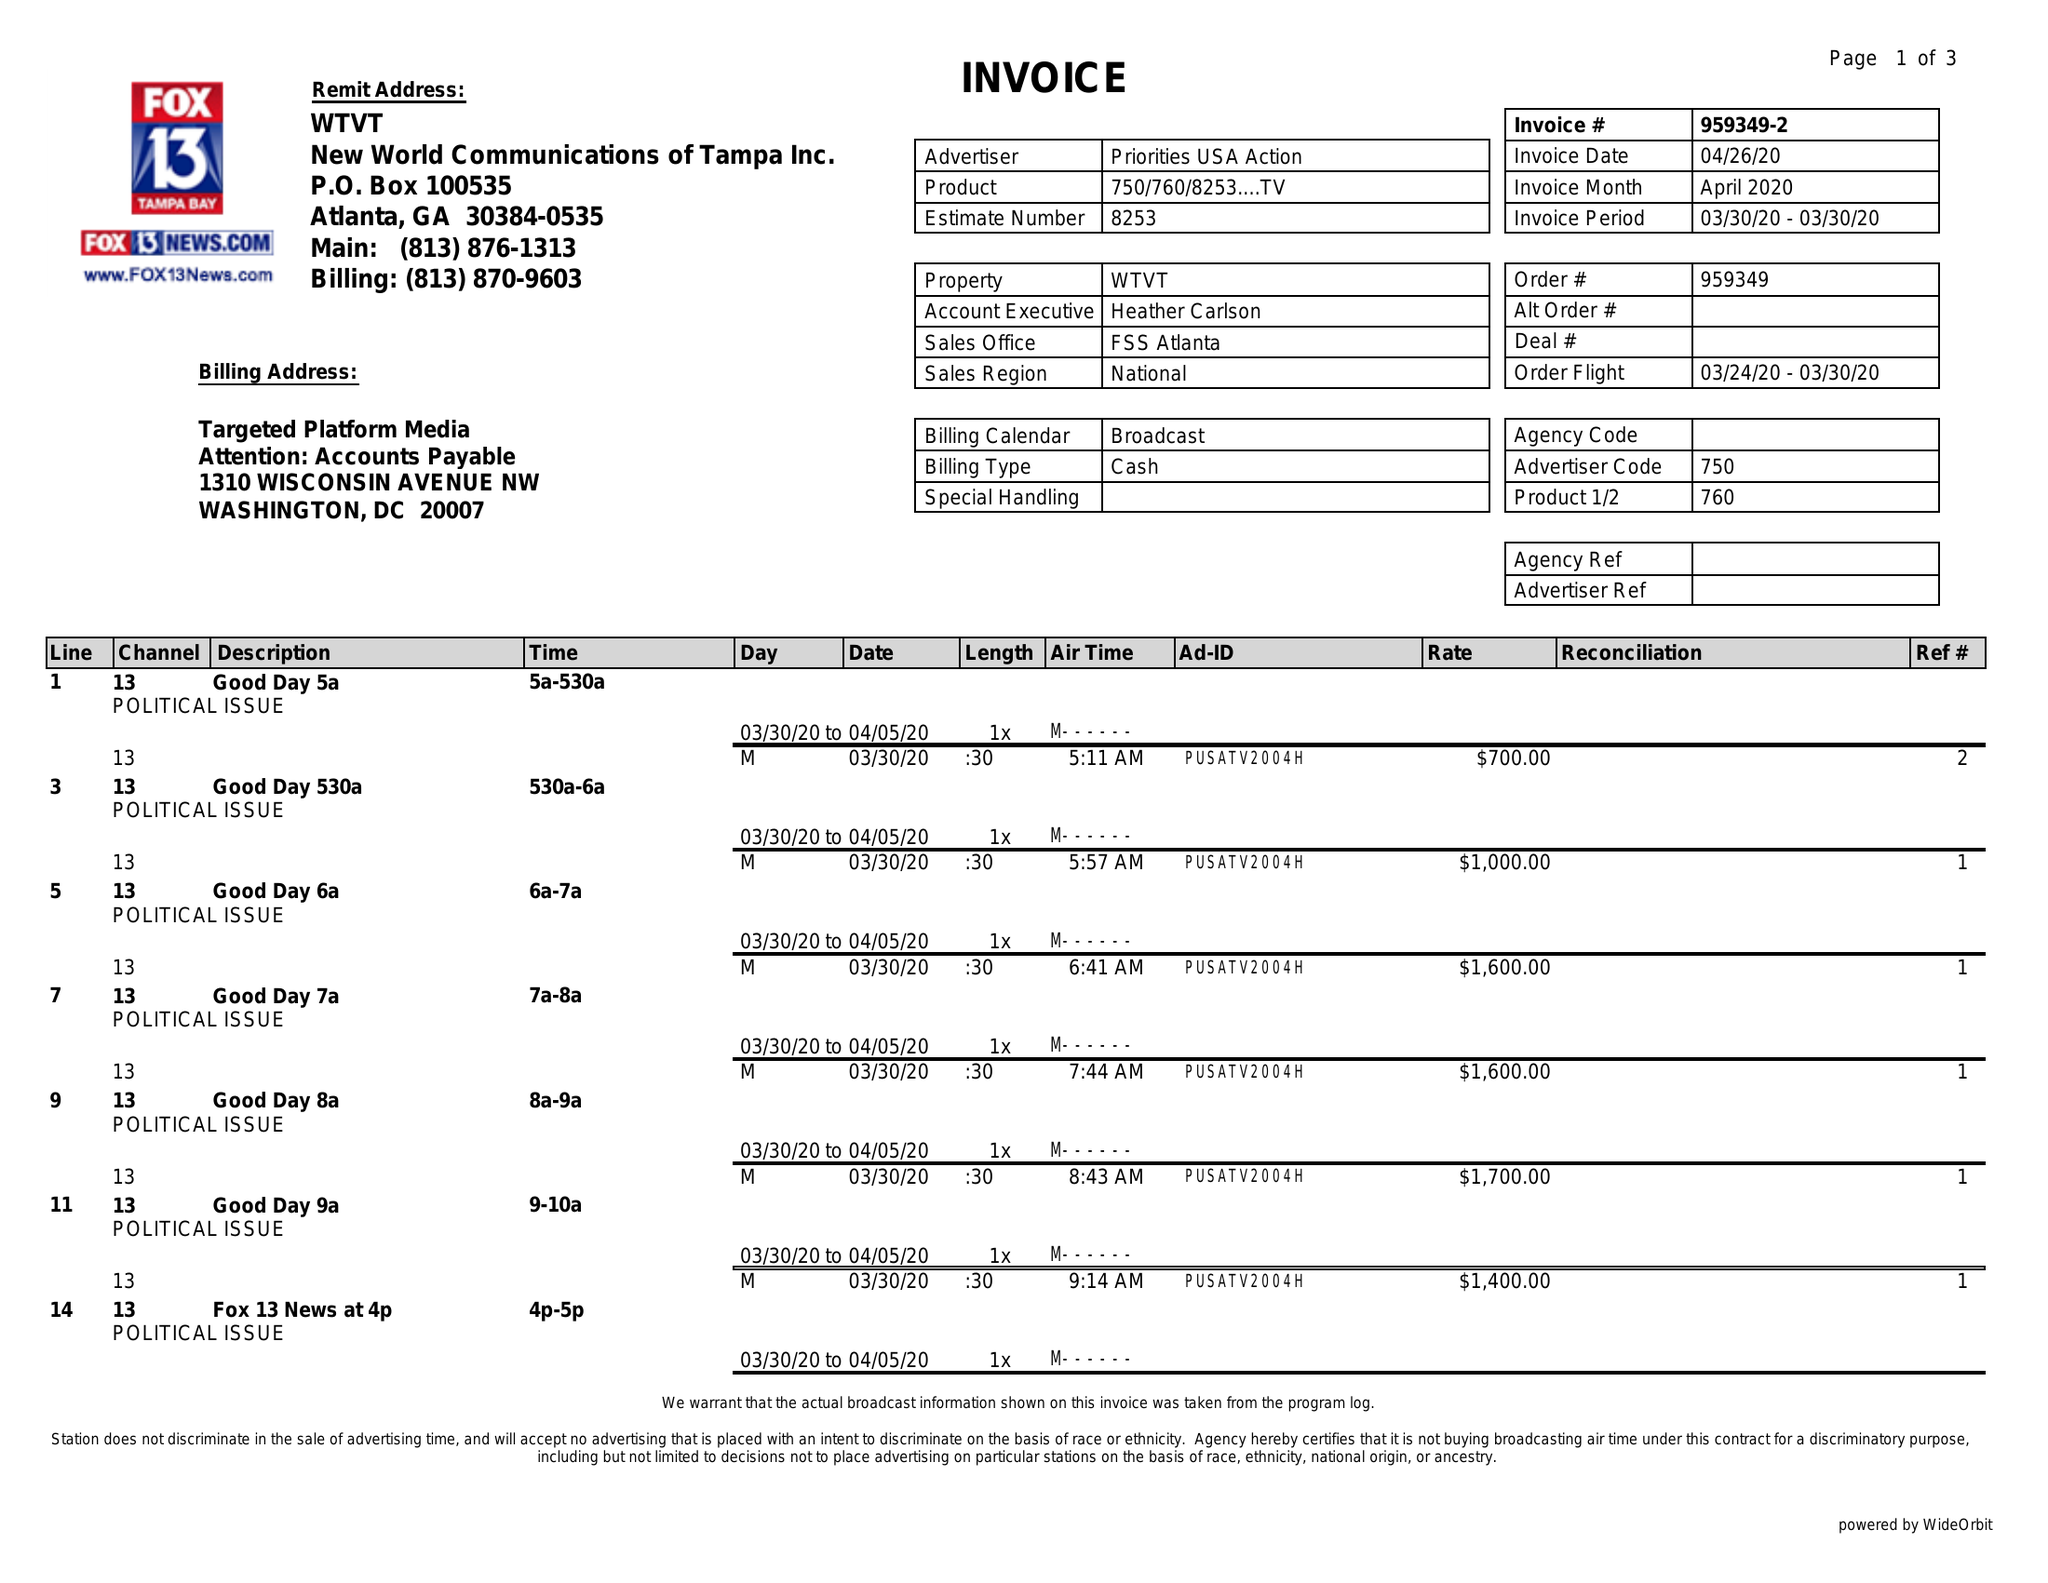What is the value for the flight_to?
Answer the question using a single word or phrase. 03/30/20 